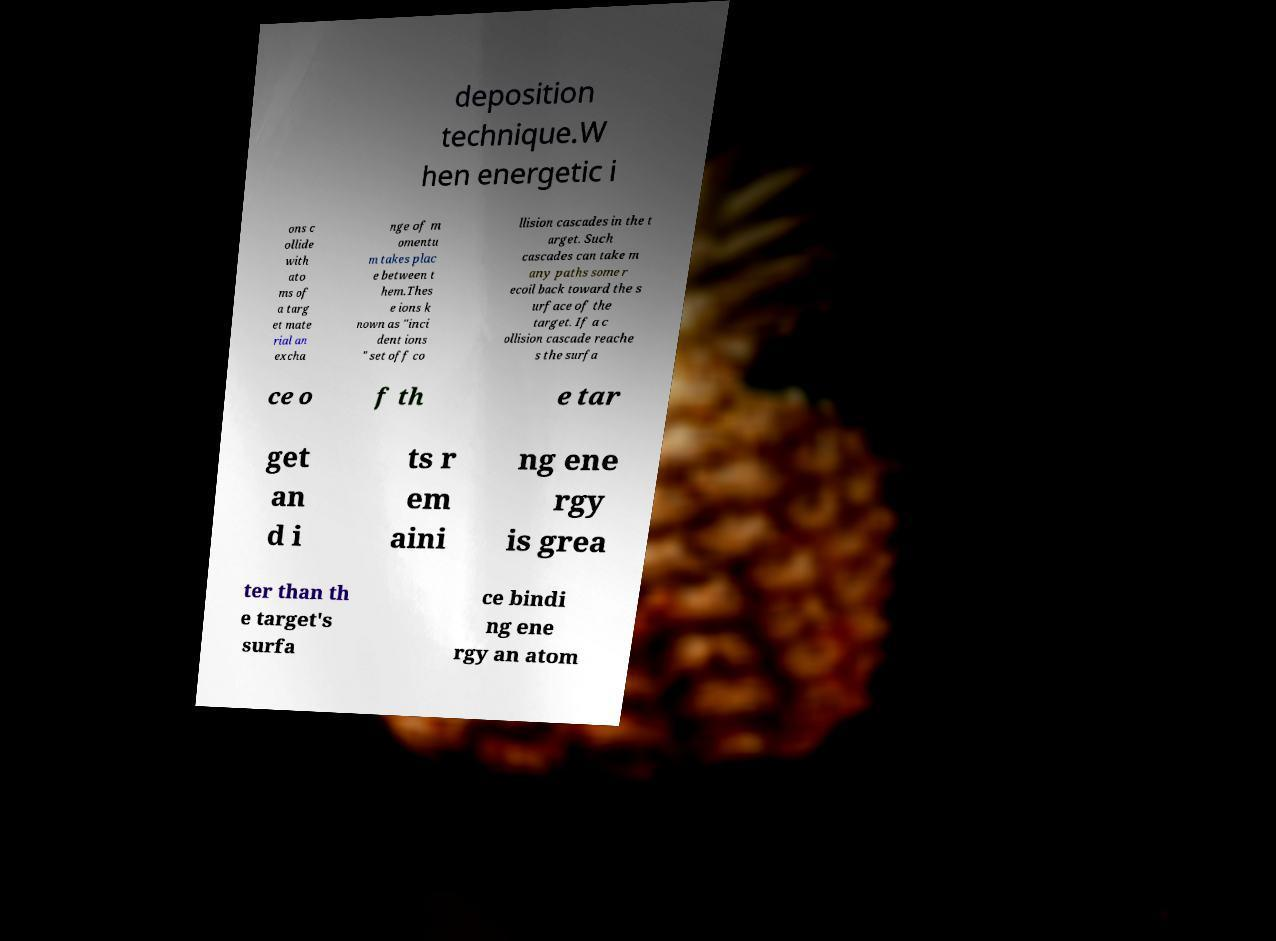I need the written content from this picture converted into text. Can you do that? deposition technique.W hen energetic i ons c ollide with ato ms of a targ et mate rial an excha nge of m omentu m takes plac e between t hem.Thes e ions k nown as "inci dent ions " set off co llision cascades in the t arget. Such cascades can take m any paths some r ecoil back toward the s urface of the target. If a c ollision cascade reache s the surfa ce o f th e tar get an d i ts r em aini ng ene rgy is grea ter than th e target's surfa ce bindi ng ene rgy an atom 